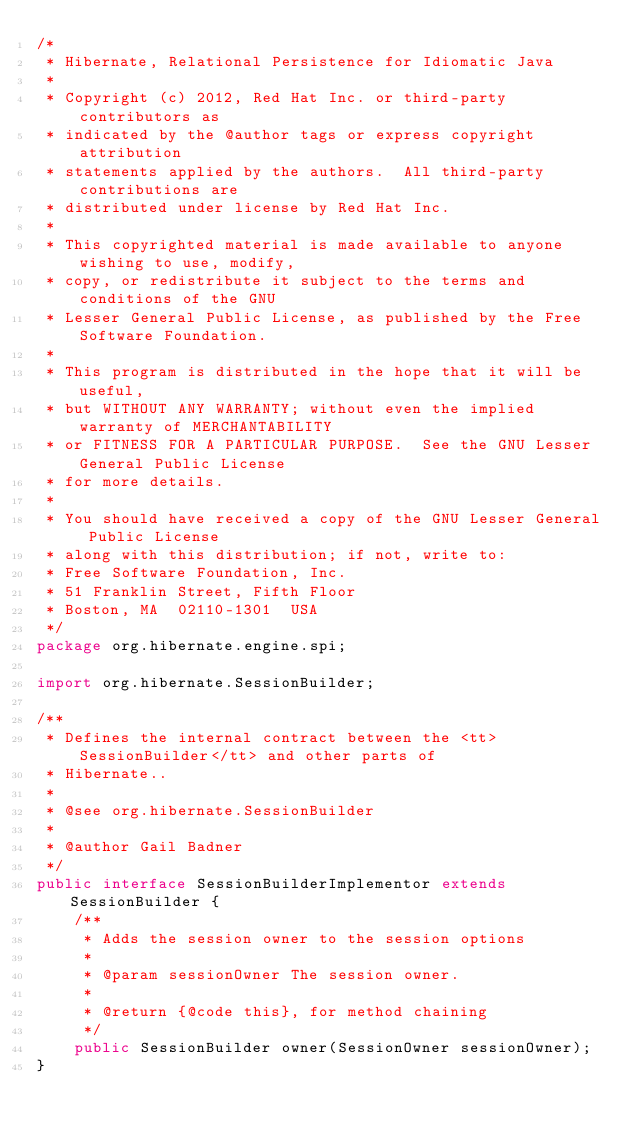Convert code to text. <code><loc_0><loc_0><loc_500><loc_500><_Java_>/*
 * Hibernate, Relational Persistence for Idiomatic Java
 *
 * Copyright (c) 2012, Red Hat Inc. or third-party contributors as
 * indicated by the @author tags or express copyright attribution
 * statements applied by the authors.  All third-party contributions are
 * distributed under license by Red Hat Inc.
 *
 * This copyrighted material is made available to anyone wishing to use, modify,
 * copy, or redistribute it subject to the terms and conditions of the GNU
 * Lesser General Public License, as published by the Free Software Foundation.
 *
 * This program is distributed in the hope that it will be useful,
 * but WITHOUT ANY WARRANTY; without even the implied warranty of MERCHANTABILITY
 * or FITNESS FOR A PARTICULAR PURPOSE.  See the GNU Lesser General Public License
 * for more details.
 *
 * You should have received a copy of the GNU Lesser General Public License
 * along with this distribution; if not, write to:
 * Free Software Foundation, Inc.
 * 51 Franklin Street, Fifth Floor
 * Boston, MA  02110-1301  USA
 */
package org.hibernate.engine.spi;

import org.hibernate.SessionBuilder;

/**
 * Defines the internal contract between the <tt>SessionBuilder</tt> and other parts of
 * Hibernate..
 *
 * @see org.hibernate.SessionBuilder
 *
 * @author Gail Badner
 */
public interface SessionBuilderImplementor extends SessionBuilder {
	/**
	 * Adds the session owner to the session options
	 *
	 * @param sessionOwner The session owner.
	 *
	 * @return {@code this}, for method chaining
	 */
	public SessionBuilder owner(SessionOwner sessionOwner);
}
</code> 